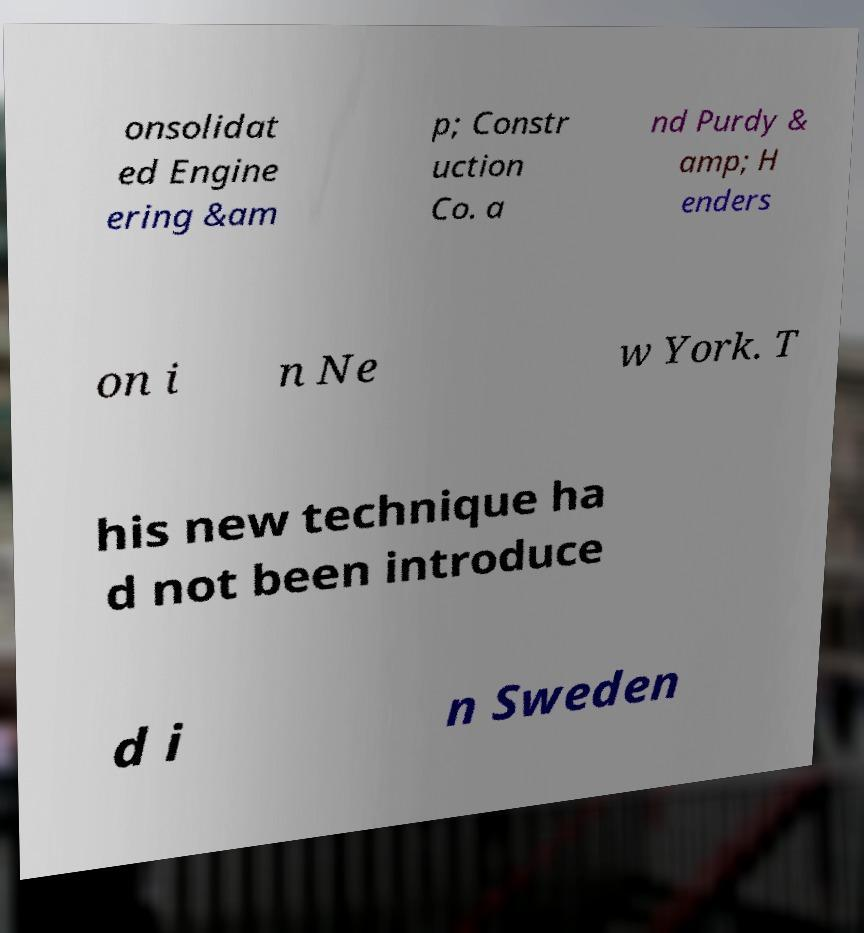Could you extract and type out the text from this image? onsolidat ed Engine ering &am p; Constr uction Co. a nd Purdy & amp; H enders on i n Ne w York. T his new technique ha d not been introduce d i n Sweden 